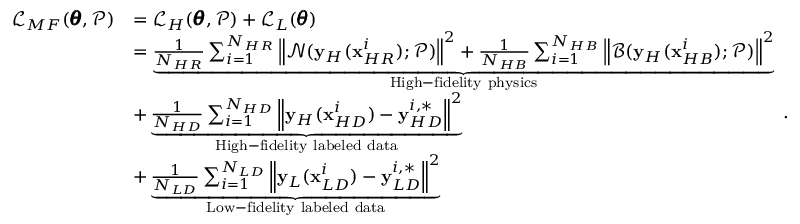Convert formula to latex. <formula><loc_0><loc_0><loc_500><loc_500>\begin{array} { r l } { \mathcal { L } _ { M F } ( \pm b { \theta } , \mathcal { P } ) } & { = \mathcal { L } _ { H } ( \pm b { \theta } , \mathcal { P } ) + \mathcal { L } _ { L } ( \pm b { \theta } ) } \\ & { = \underbrace { \frac { 1 } { N _ { H R } } \sum _ { i = 1 } ^ { N _ { H R } } { \left \| \mathcal { N } ( y _ { H } ( x _ { H R } ^ { i } ) ; \mathcal { P } ) \right \| ^ { 2 } } + \frac { 1 } { N _ { H B } } \sum _ { i = 1 } ^ { N _ { H B } } { \left \| \mathcal { B } ( y _ { H } ( x _ { H B } ^ { i } ) ; \mathcal { P } ) \right \| ^ { 2 } } } _ { H i g h - f i d e l i t y p h y s i c s } } \\ & { + \underbrace { \frac { 1 } { N _ { H D } } \sum _ { i = 1 } ^ { N _ { H D } } { \left \| y _ { H } ( x _ { H D } ^ { i } ) - y _ { H D } ^ { i , * } \right \| ^ { 2 } } } _ { H i g h - f i d e l i t y l a b e l e d d a t a } } \\ & { + \underbrace { \frac { 1 } { N _ { L D } } \sum _ { i = 1 } ^ { N _ { L D } } { \left \| y _ { L } ( x _ { L D } ^ { i } ) - y _ { L D } ^ { i , * } \right \| ^ { 2 } } } _ { L o w - f i d e l i t y l a b e l e d d a t a } } \end{array} .</formula> 